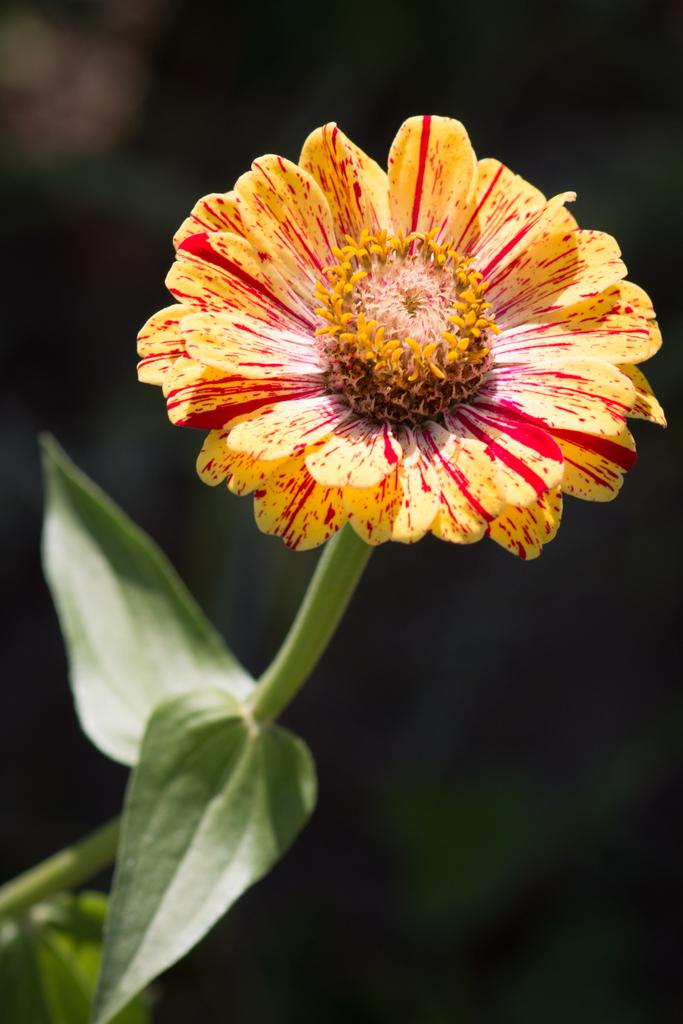What type of flower is in the image? There is a yellow and red flower in the image. What parts of the flower can be seen? The flower has a stem and leaves associated with the stem. What is the color of the background in the image? The background of the image is dark. How many copies of the sock are present in the image? There is no sock present in the image, so it is not possible to determine the number of copies. 